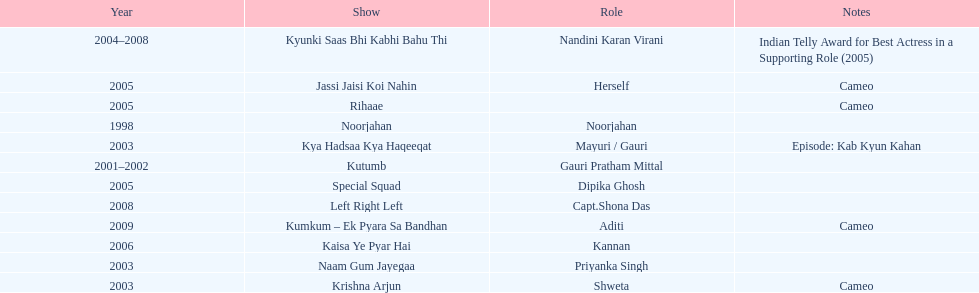Which television show was gauri in for the longest amount of time? Kyunki Saas Bhi Kabhi Bahu Thi. 